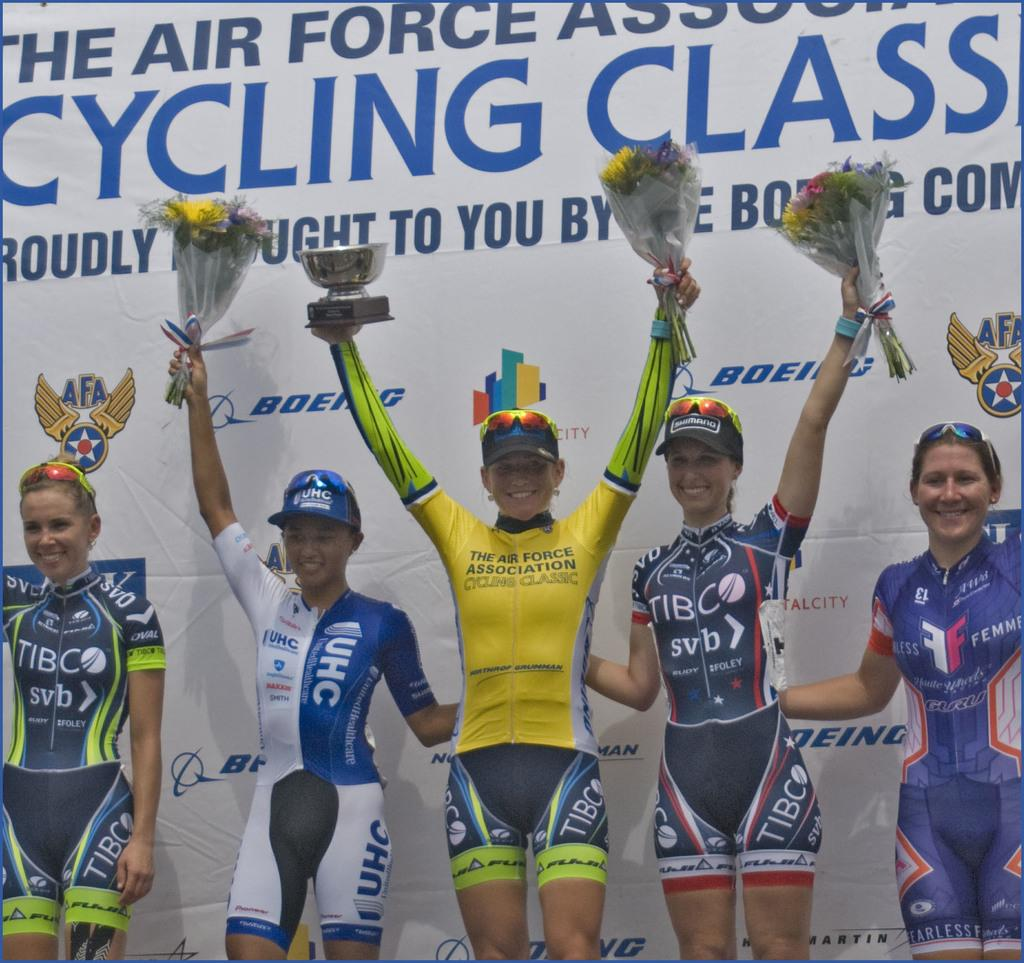<image>
Share a concise interpretation of the image provided. The posted behind the winners reads Cycling Class. 